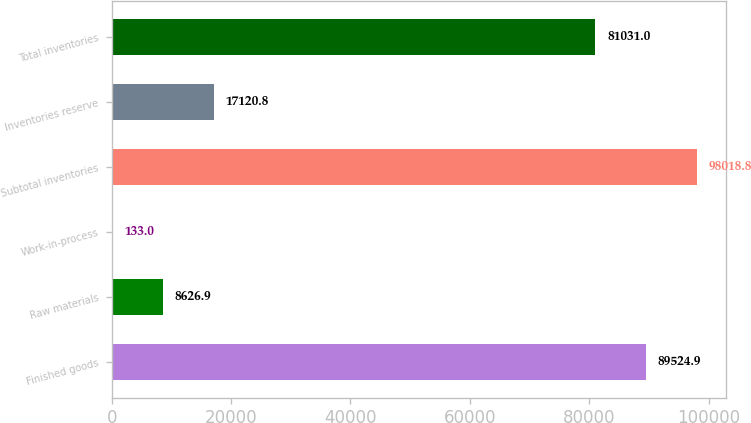Convert chart. <chart><loc_0><loc_0><loc_500><loc_500><bar_chart><fcel>Finished goods<fcel>Raw materials<fcel>Work-in-process<fcel>Subtotal inventories<fcel>Inventories reserve<fcel>Total inventories<nl><fcel>89524.9<fcel>8626.9<fcel>133<fcel>98018.8<fcel>17120.8<fcel>81031<nl></chart> 